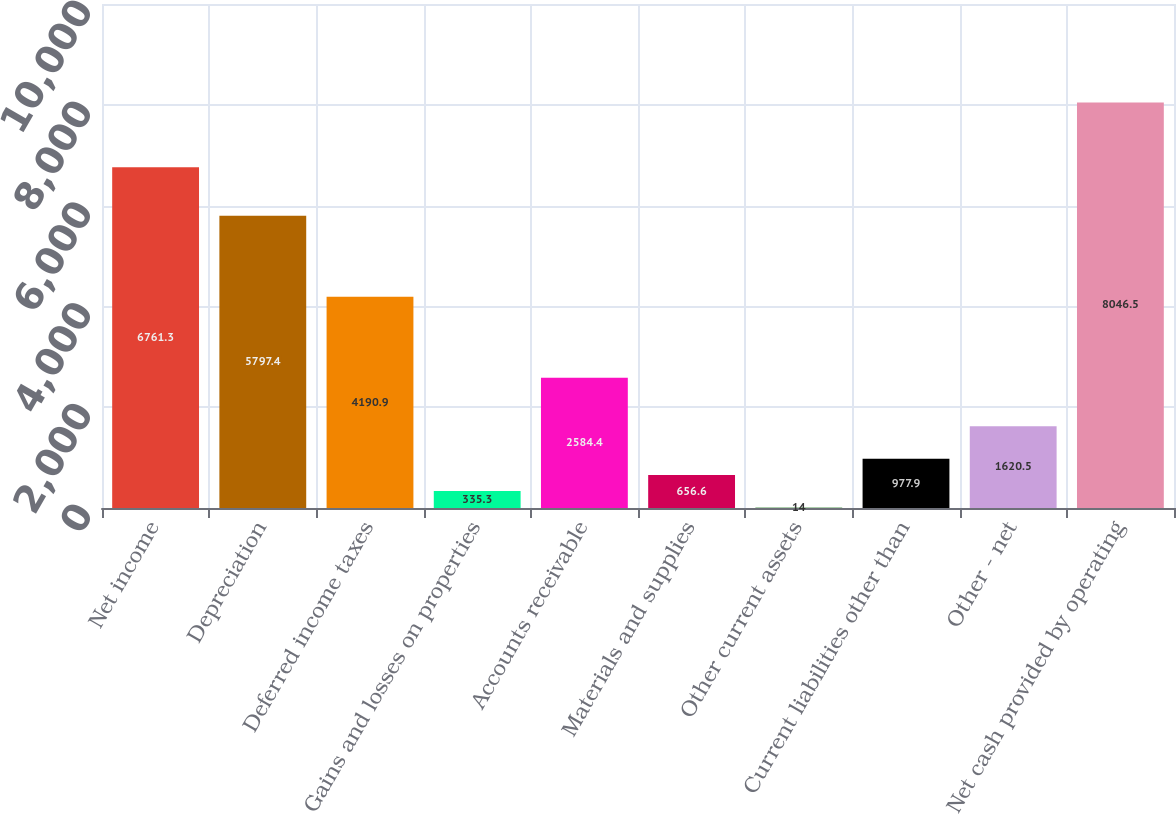Convert chart. <chart><loc_0><loc_0><loc_500><loc_500><bar_chart><fcel>Net income<fcel>Depreciation<fcel>Deferred income taxes<fcel>Gains and losses on properties<fcel>Accounts receivable<fcel>Materials and supplies<fcel>Other current assets<fcel>Current liabilities other than<fcel>Other - net<fcel>Net cash provided by operating<nl><fcel>6761.3<fcel>5797.4<fcel>4190.9<fcel>335.3<fcel>2584.4<fcel>656.6<fcel>14<fcel>977.9<fcel>1620.5<fcel>8046.5<nl></chart> 